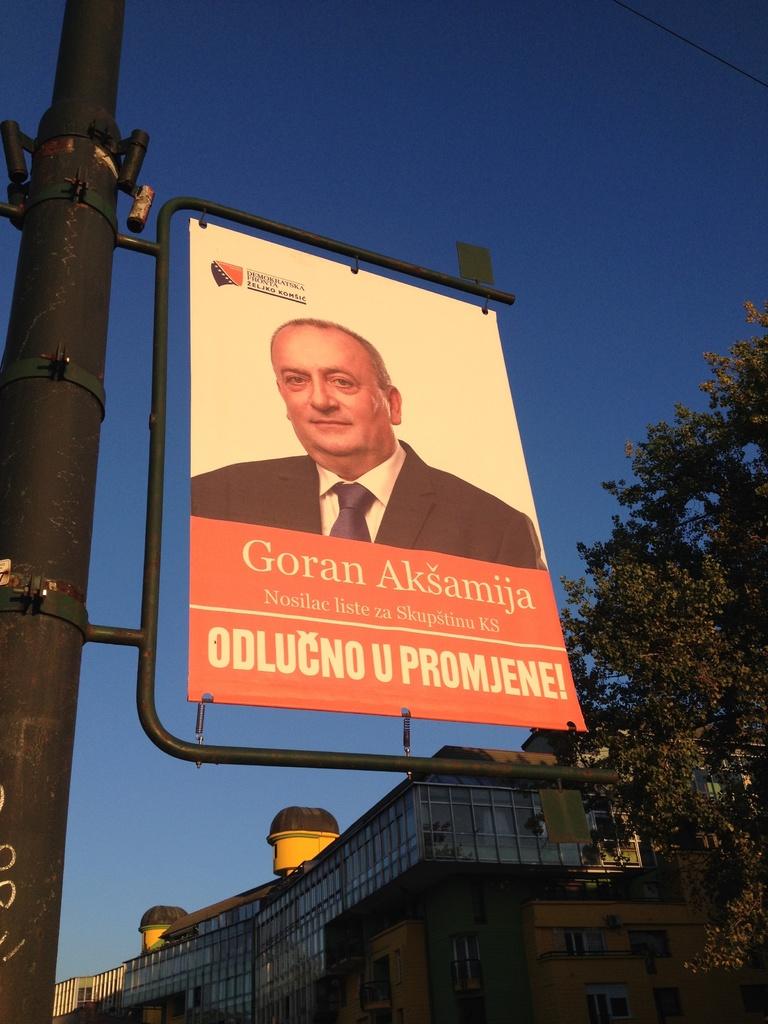Who is this man?
Ensure brevity in your answer.  Goran aksamija. 